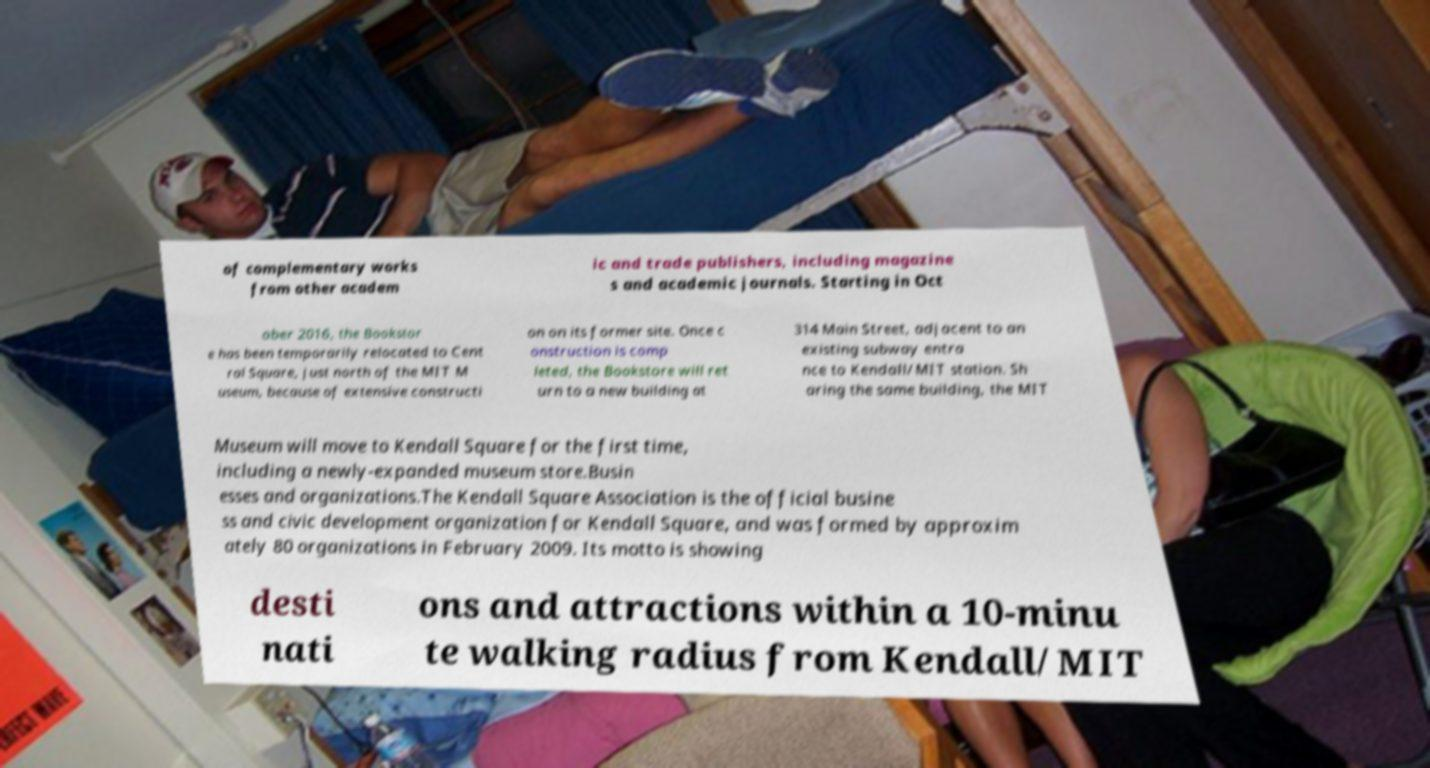Can you read and provide the text displayed in the image?This photo seems to have some interesting text. Can you extract and type it out for me? of complementary works from other academ ic and trade publishers, including magazine s and academic journals. Starting in Oct ober 2016, the Bookstor e has been temporarily relocated to Cent ral Square, just north of the MIT M useum, because of extensive constructi on on its former site. Once c onstruction is comp leted, the Bookstore will ret urn to a new building at 314 Main Street, adjacent to an existing subway entra nce to Kendall/MIT station. Sh aring the same building, the MIT Museum will move to Kendall Square for the first time, including a newly-expanded museum store.Busin esses and organizations.The Kendall Square Association is the official busine ss and civic development organization for Kendall Square, and was formed by approxim ately 80 organizations in February 2009. Its motto is showing desti nati ons and attractions within a 10-minu te walking radius from Kendall/MIT 